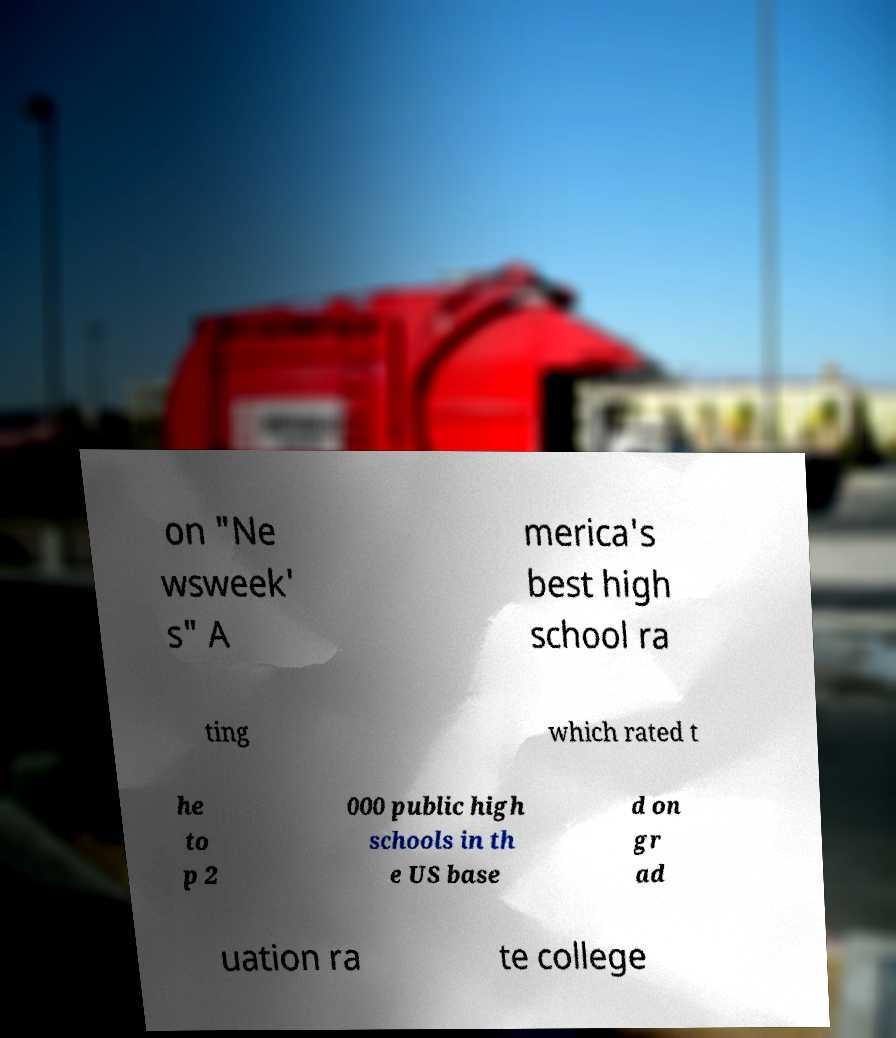Please identify and transcribe the text found in this image. on "Ne wsweek' s" A merica's best high school ra ting which rated t he to p 2 000 public high schools in th e US base d on gr ad uation ra te college 